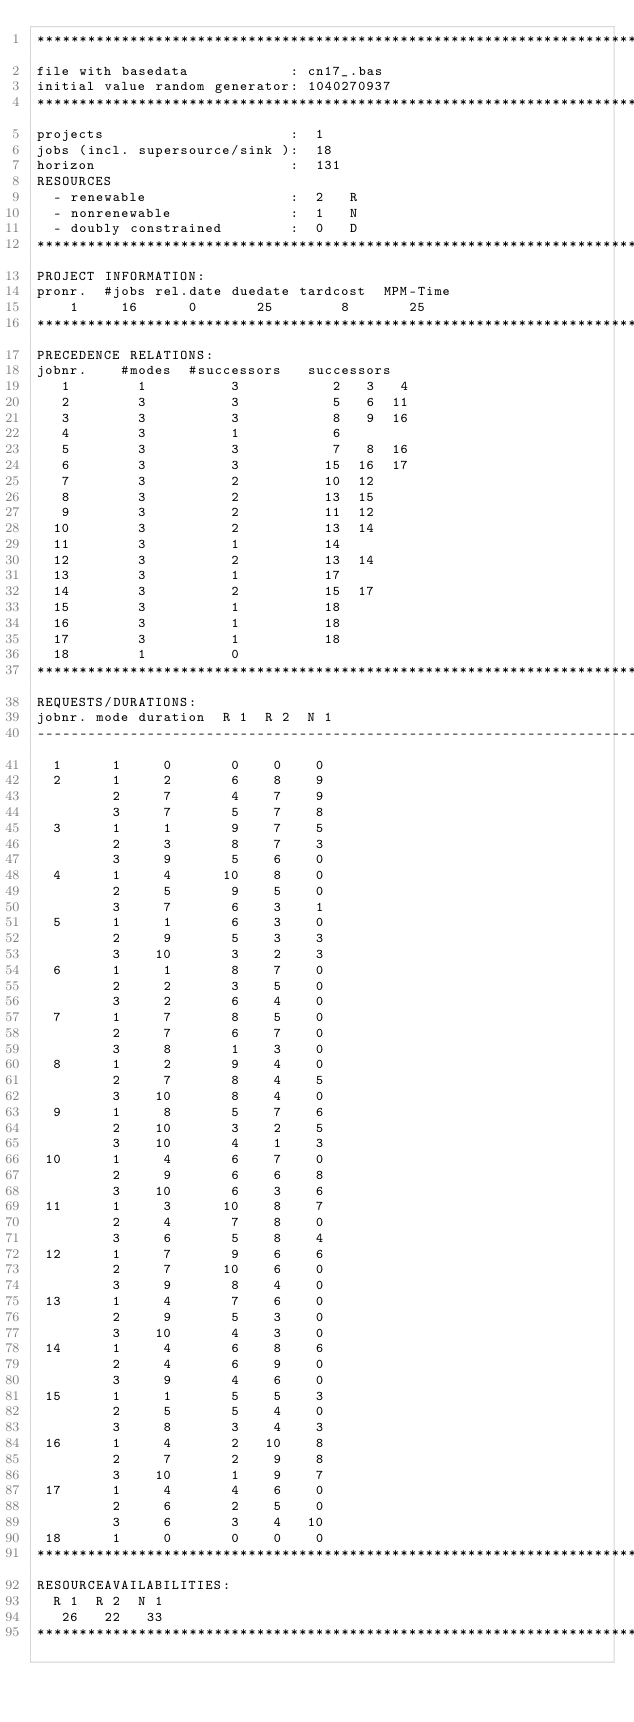<code> <loc_0><loc_0><loc_500><loc_500><_ObjectiveC_>************************************************************************
file with basedata            : cn17_.bas
initial value random generator: 1040270937
************************************************************************
projects                      :  1
jobs (incl. supersource/sink ):  18
horizon                       :  131
RESOURCES
  - renewable                 :  2   R
  - nonrenewable              :  1   N
  - doubly constrained        :  0   D
************************************************************************
PROJECT INFORMATION:
pronr.  #jobs rel.date duedate tardcost  MPM-Time
    1     16      0       25        8       25
************************************************************************
PRECEDENCE RELATIONS:
jobnr.    #modes  #successors   successors
   1        1          3           2   3   4
   2        3          3           5   6  11
   3        3          3           8   9  16
   4        3          1           6
   5        3          3           7   8  16
   6        3          3          15  16  17
   7        3          2          10  12
   8        3          2          13  15
   9        3          2          11  12
  10        3          2          13  14
  11        3          1          14
  12        3          2          13  14
  13        3          1          17
  14        3          2          15  17
  15        3          1          18
  16        3          1          18
  17        3          1          18
  18        1          0        
************************************************************************
REQUESTS/DURATIONS:
jobnr. mode duration  R 1  R 2  N 1
------------------------------------------------------------------------
  1      1     0       0    0    0
  2      1     2       6    8    9
         2     7       4    7    9
         3     7       5    7    8
  3      1     1       9    7    5
         2     3       8    7    3
         3     9       5    6    0
  4      1     4      10    8    0
         2     5       9    5    0
         3     7       6    3    1
  5      1     1       6    3    0
         2     9       5    3    3
         3    10       3    2    3
  6      1     1       8    7    0
         2     2       3    5    0
         3     2       6    4    0
  7      1     7       8    5    0
         2     7       6    7    0
         3     8       1    3    0
  8      1     2       9    4    0
         2     7       8    4    5
         3    10       8    4    0
  9      1     8       5    7    6
         2    10       3    2    5
         3    10       4    1    3
 10      1     4       6    7    0
         2     9       6    6    8
         3    10       6    3    6
 11      1     3      10    8    7
         2     4       7    8    0
         3     6       5    8    4
 12      1     7       9    6    6
         2     7      10    6    0
         3     9       8    4    0
 13      1     4       7    6    0
         2     9       5    3    0
         3    10       4    3    0
 14      1     4       6    8    6
         2     4       6    9    0
         3     9       4    6    0
 15      1     1       5    5    3
         2     5       5    4    0
         3     8       3    4    3
 16      1     4       2   10    8
         2     7       2    9    8
         3    10       1    9    7
 17      1     4       4    6    0
         2     6       2    5    0
         3     6       3    4   10
 18      1     0       0    0    0
************************************************************************
RESOURCEAVAILABILITIES:
  R 1  R 2  N 1
   26   22   33
************************************************************************
</code> 